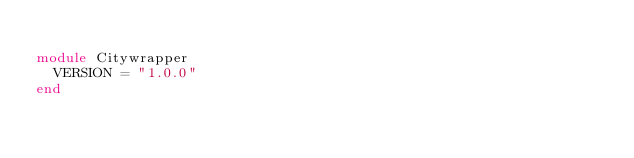Convert code to text. <code><loc_0><loc_0><loc_500><loc_500><_Ruby_>
module Citywrapper
  VERSION = "1.0.0"
end
</code> 